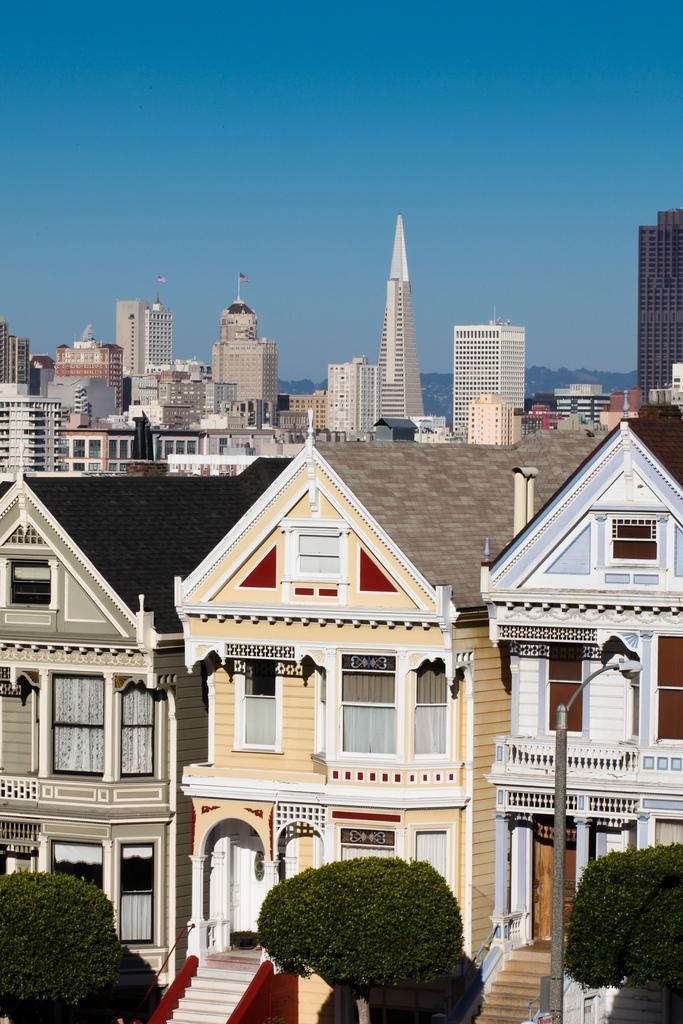Could you give a brief overview of what you see in this image? There are three trees and there are buildings in the background. 